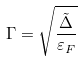<formula> <loc_0><loc_0><loc_500><loc_500>\Gamma = \sqrt { \frac { \tilde { \Delta } } { \varepsilon _ { F } } }</formula> 